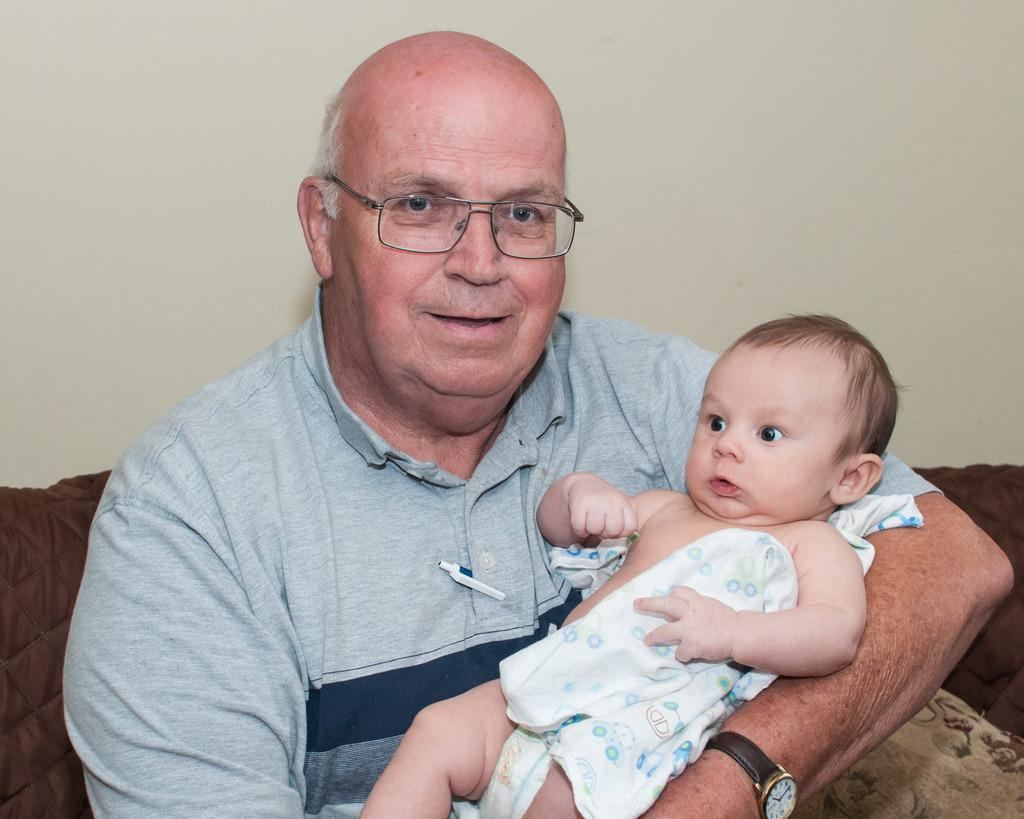Who is the main subject in the image? The main subject in the image is an old person. What is the old person doing in the image? The old person is holding a baby in the image. What can be seen in the background of the image? There is a wall in the background of the image. What type of bubble is floating near the old person in the image? There is no bubble present in the image. Is the old person a representative of a particular organization in the image? The image does not provide any information about the old person's affiliations or roles, so it cannot be determined if they are a representative of any organization. 